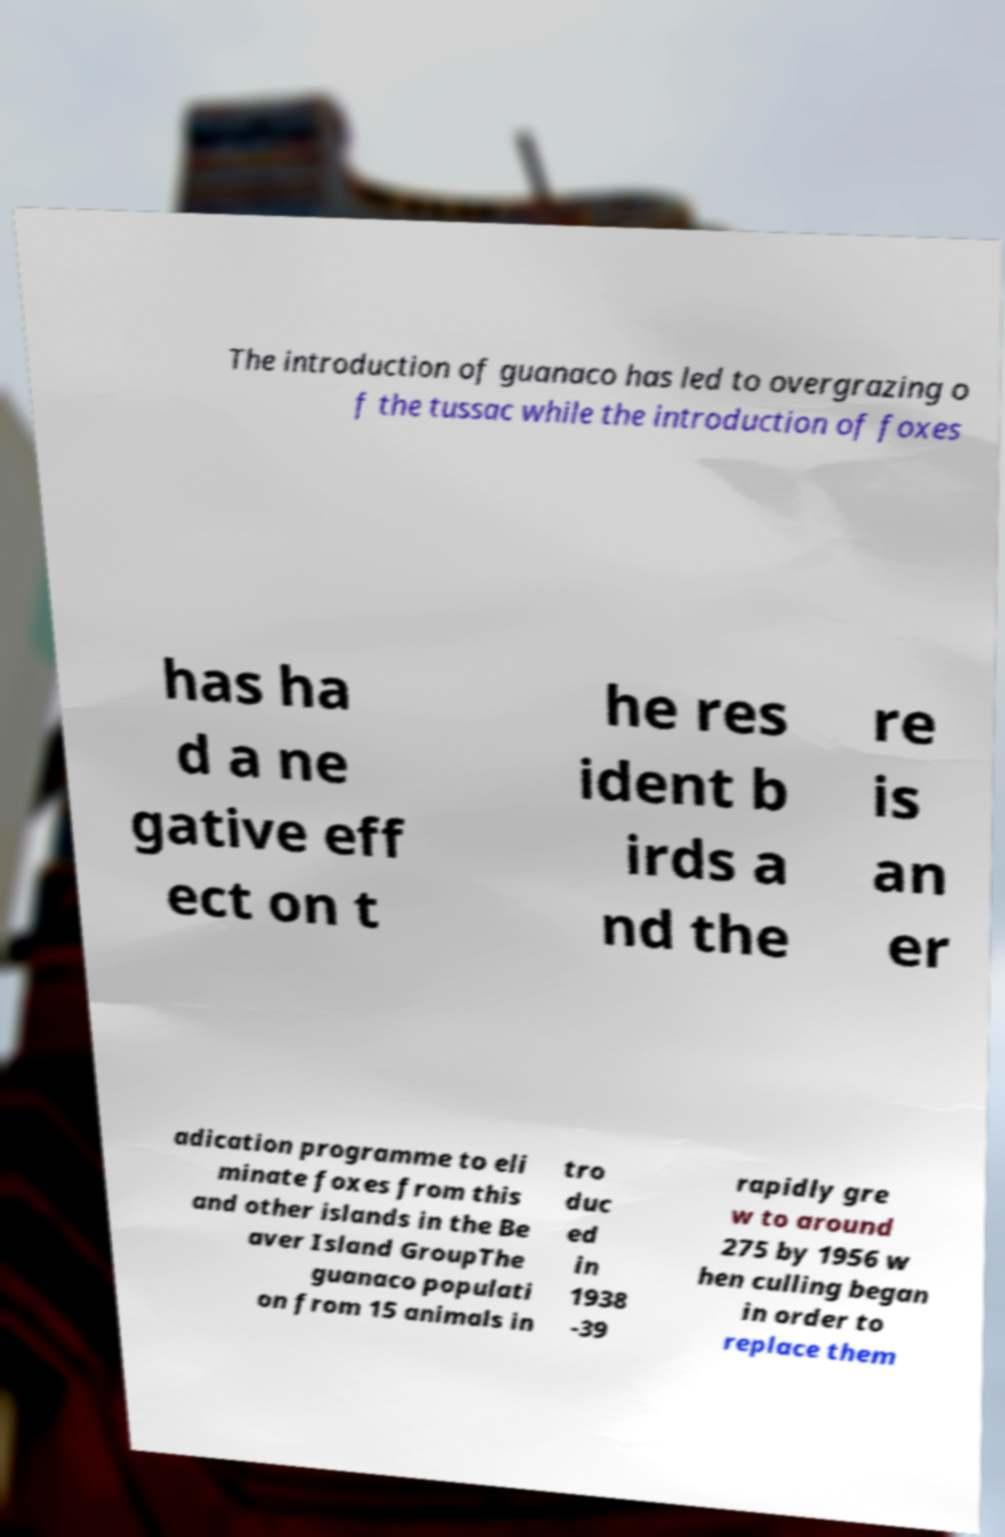For documentation purposes, I need the text within this image transcribed. Could you provide that? The introduction of guanaco has led to overgrazing o f the tussac while the introduction of foxes has ha d a ne gative eff ect on t he res ident b irds a nd the re is an er adication programme to eli minate foxes from this and other islands in the Be aver Island GroupThe guanaco populati on from 15 animals in tro duc ed in 1938 -39 rapidly gre w to around 275 by 1956 w hen culling began in order to replace them 